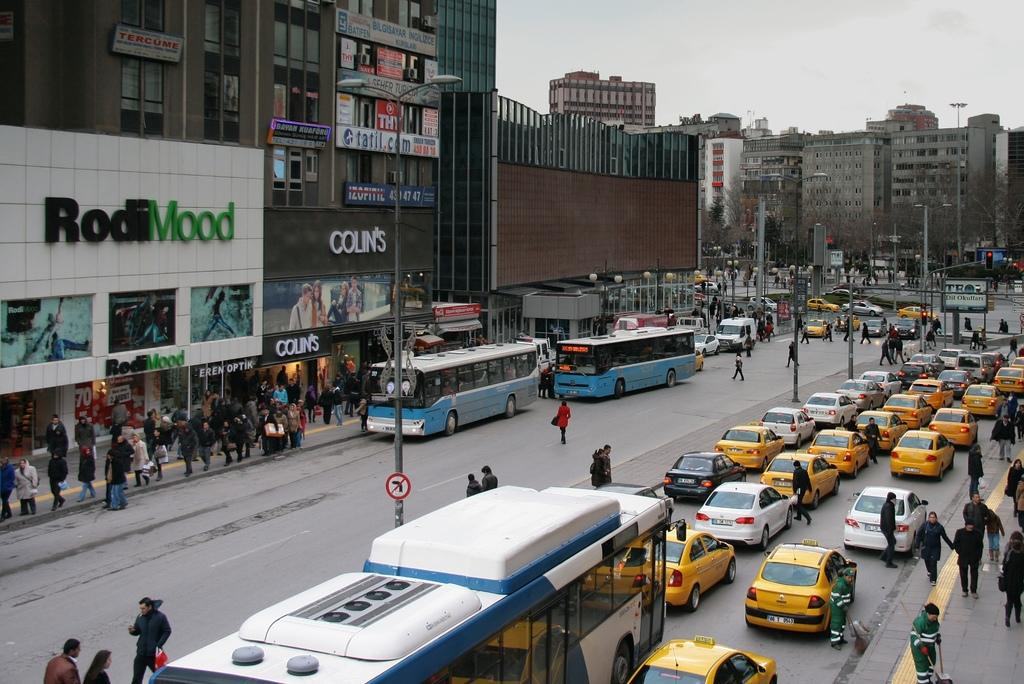<image>
Describe the image concisely. two blue buses are sitting outside the Colin's store 